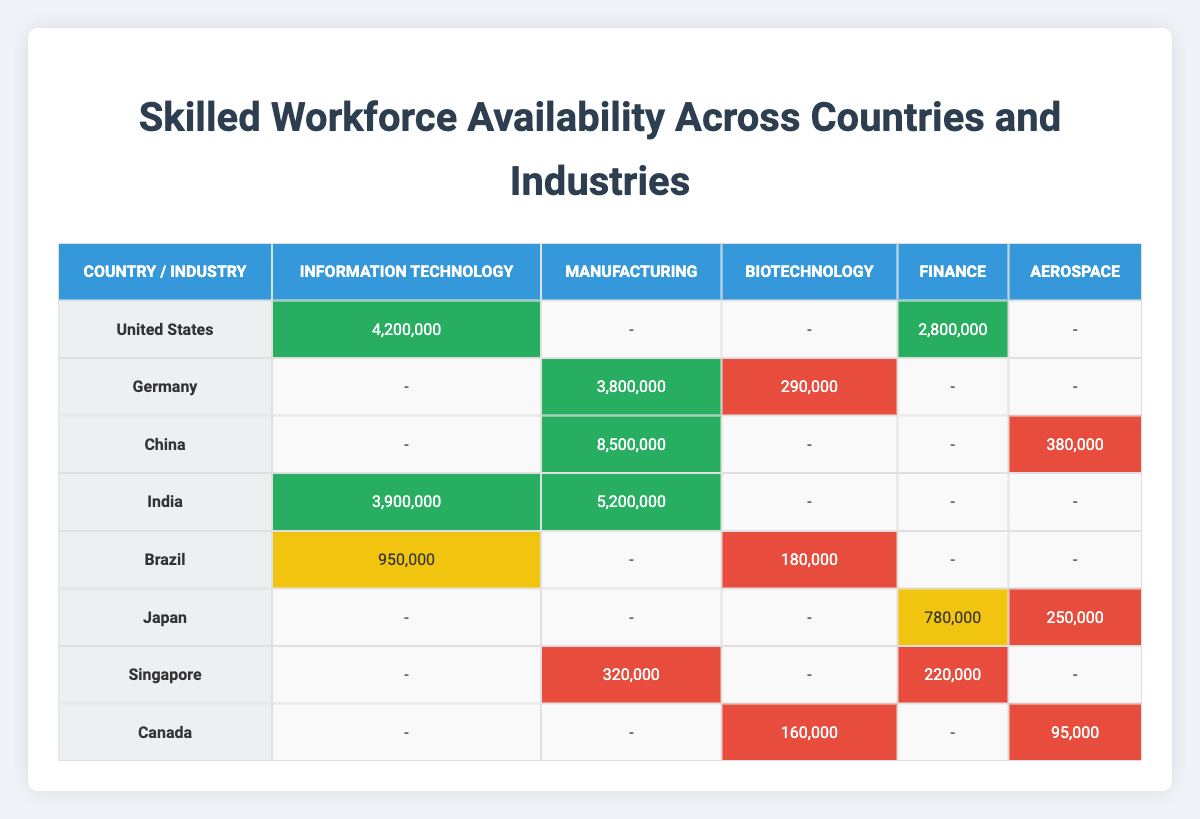What is the skilled workforce in Information Technology in China? According to the table, the skilled workforce in Information Technology for China is not directly stated. By checking the data for China under the Information Technology column, we find that there is no entry listed for it.
Answer: 0 Which country has the highest skilled workforce in Manufacturing? Analyzing the Manufacturing row, we see that China has the highest skilled workforce with 8,500,000 workers.
Answer: China What is the total skilled workforce in Biotechnology across all listed countries? Summing the skilled workforce in Biotechnology across listed countries: Brazil (180,000) + Germany (290,000) + Canada (160,000) = 630,000.
Answer: 630,000 Is there a skilled workforce of over 4 million in any industry in the United States? Looking at the table, the skilled workforce in Information Technology (4,200,000) and Finance (2,800,000) are listed. Since 4,200,000 exceeds 4 million, the answer is yes.
Answer: Yes What is the difference in skilled workforce availability between the highest and lowest countries for the Aerospace industry? In the Aerospace industry, China has 380,000, while Canada has 95,000 skilled workers. The difference is 380,000 - 95,000 = 285,000.
Answer: 285,000 Which industry has the highest skilled workforce in India? Checking the rows for India, we find the skilled workforce in Manufacturing (5,200,000) is greater than in Information Technology (3,900,000).
Answer: Manufacturing Which two countries have a skilled workforce in Biotechnology? The countries listed with a skilled workforce in Biotechnology are Brazil and Canada based on the table's data.
Answer: Brazil and Canada How many countries have a skilled workforce in Finance? By reviewing the Finance column, we see that the countries with skilled workforce are United States, Singapore, and Japan, totaling three countries.
Answer: 3 What is the average skilled workforce in the Manufacturing industry across all countries? The skilled workforce for Manufacturing is: Germany (3,800,000), China (8,500,000), India (5,200,000), and Singapore (320,000). Summing them gives 3,800,000 + 8,500,000 + 5,200,000 + 320,000 = 17,820,000. Dividing by the number of countries (4) gives an average of 4,455,000.
Answer: 4,455,000 Does Japan have a skilled workforce in Information Technology? Checking the Information Technology column for Japan, we find there is no entry listed, so the answer is no.
Answer: No 